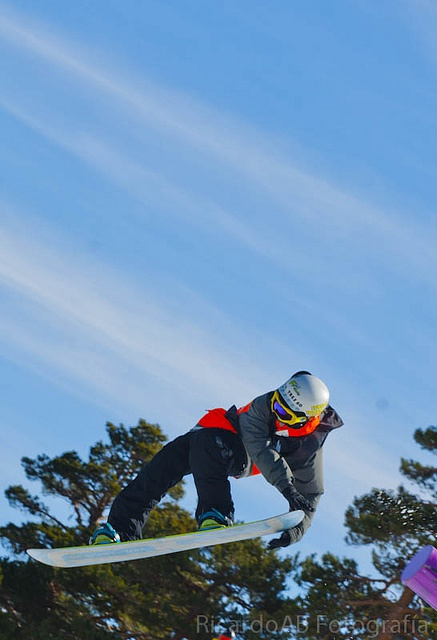Describe the objects in this image and their specific colors. I can see people in lightblue, black, navy, and gray tones, snowboard in lightblue, darkgray, gray, and black tones, and kite in lightblue, blue, and purple tones in this image. 